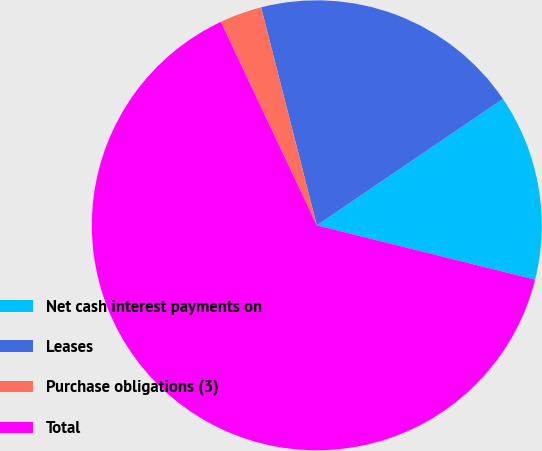Convert chart. <chart><loc_0><loc_0><loc_500><loc_500><pie_chart><fcel>Net cash interest payments on<fcel>Leases<fcel>Purchase obligations (3)<fcel>Total<nl><fcel>13.38%<fcel>19.49%<fcel>3.03%<fcel>64.11%<nl></chart> 